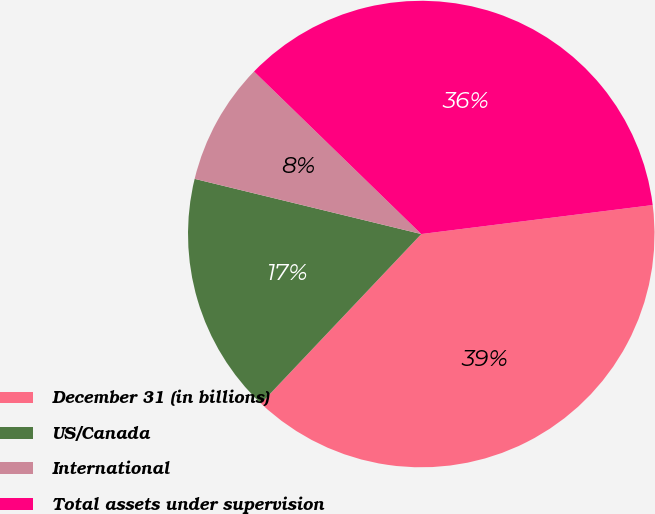Convert chart. <chart><loc_0><loc_0><loc_500><loc_500><pie_chart><fcel>December 31 (in billions)<fcel>US/Canada<fcel>International<fcel>Total assets under supervision<nl><fcel>39.04%<fcel>16.74%<fcel>8.47%<fcel>35.74%<nl></chart> 